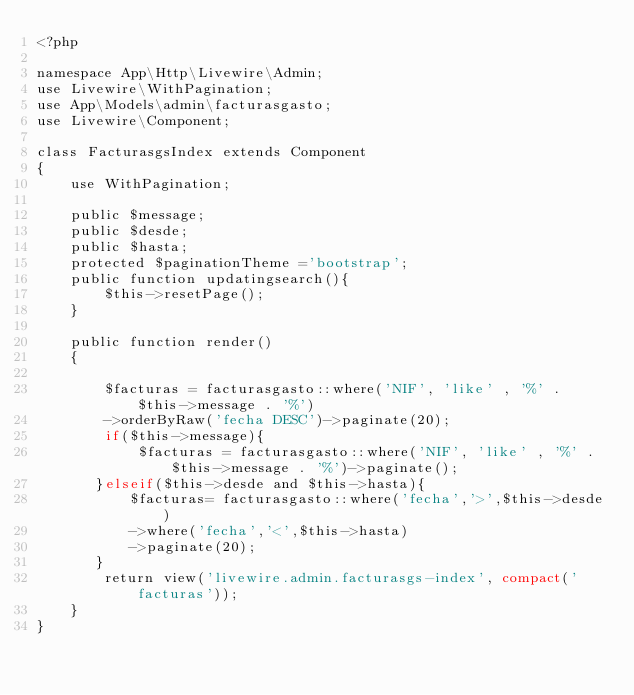<code> <loc_0><loc_0><loc_500><loc_500><_PHP_><?php

namespace App\Http\Livewire\Admin;
use Livewire\WithPagination;
use App\Models\admin\facturasgasto;
use Livewire\Component;

class FacturasgsIndex extends Component
{
    use WithPagination;

    public $message;
    public $desde;
    public $hasta;
    protected $paginationTheme ='bootstrap';
    public function updatingsearch(){
        $this->resetPage();
    }

    public function render()
    {

        $facturas = facturasgasto::where('NIF', 'like' , '%' . $this->message . '%')
        ->orderByRaw('fecha DESC')->paginate(20);
        if($this->message){       
            $facturas = facturasgasto::where('NIF', 'like' , '%' . $this->message . '%')->paginate();        
       }elseif($this->desde and $this->hasta){
           $facturas= facturasgasto::where('fecha','>',$this->desde)
           ->where('fecha','<',$this->hasta)
           ->paginate(20);
       }
        return view('livewire.admin.facturasgs-index', compact('facturas'));
    }
}
</code> 